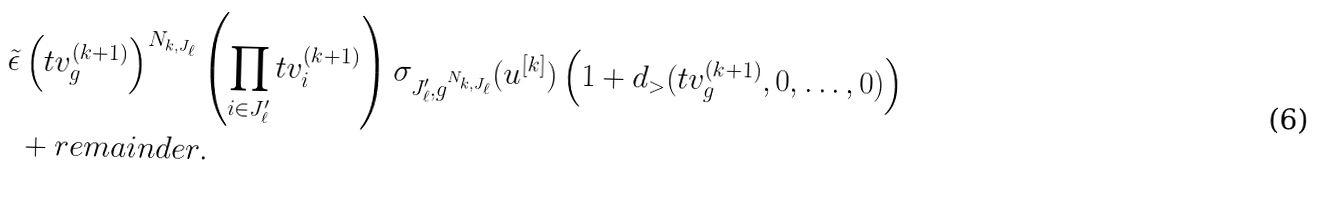<formula> <loc_0><loc_0><loc_500><loc_500>\tilde { \epsilon } & \left ( t v _ { g } ^ { ( k + 1 ) } \right ) ^ { N _ { k , J _ { \ell } } } \left ( \prod _ { i \in J _ { \ell } ^ { \prime } } t v _ { i } ^ { ( k + 1 ) } \right ) \sigma _ { J _ { \ell } ^ { \prime } , g ^ { N _ { k , J _ { \ell } } } } ( u ^ { [ k ] } ) \left ( 1 + d _ { > } ( t v ^ { ( k + 1 ) } _ { g } , 0 , \dots , 0 ) \right ) \\ & + r e m a i n d e r .</formula> 